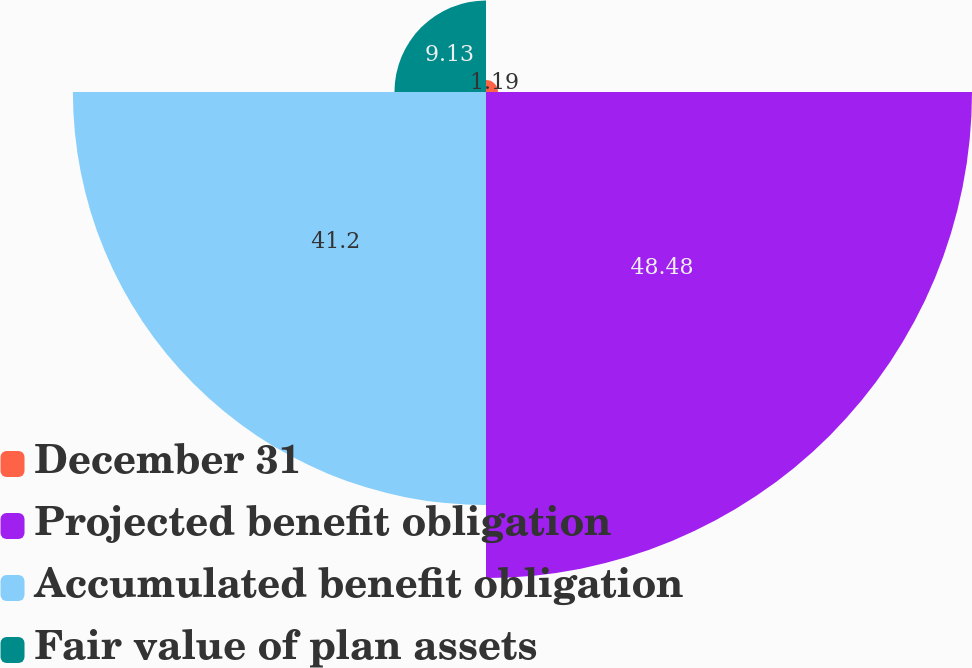Convert chart to OTSL. <chart><loc_0><loc_0><loc_500><loc_500><pie_chart><fcel>December 31<fcel>Projected benefit obligation<fcel>Accumulated benefit obligation<fcel>Fair value of plan assets<nl><fcel>1.19%<fcel>48.47%<fcel>41.2%<fcel>9.13%<nl></chart> 